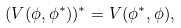Convert formula to latex. <formula><loc_0><loc_0><loc_500><loc_500>( V ( \phi , \phi ^ { * } ) ) ^ { * } = V ( \phi ^ { * } , \phi ) ,</formula> 